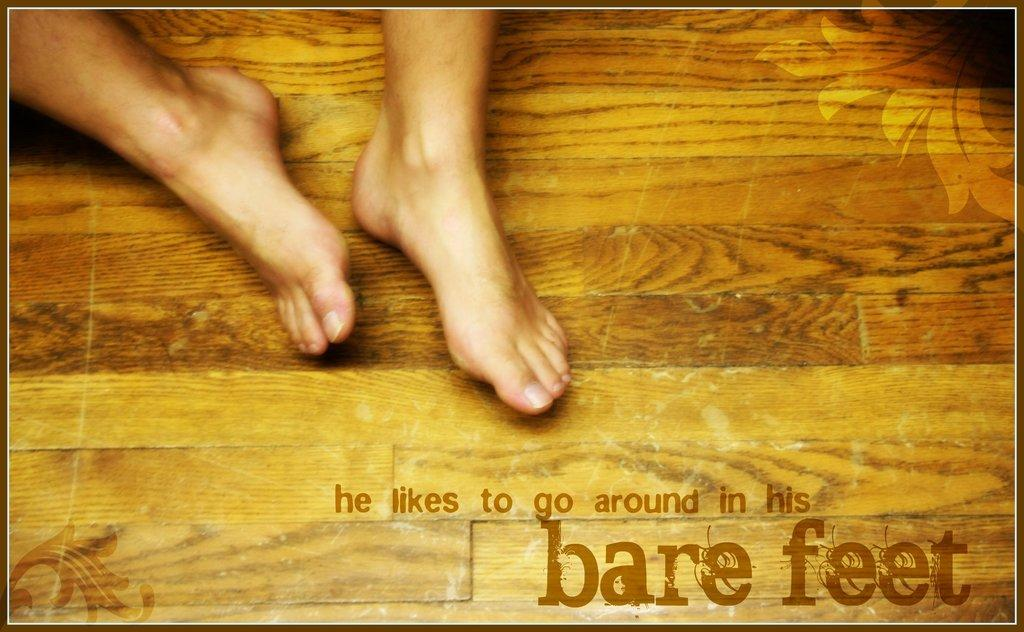<image>
Relay a brief, clear account of the picture shown. a pair of feet by words reading He Likes to Go Around in his Bare Feet 